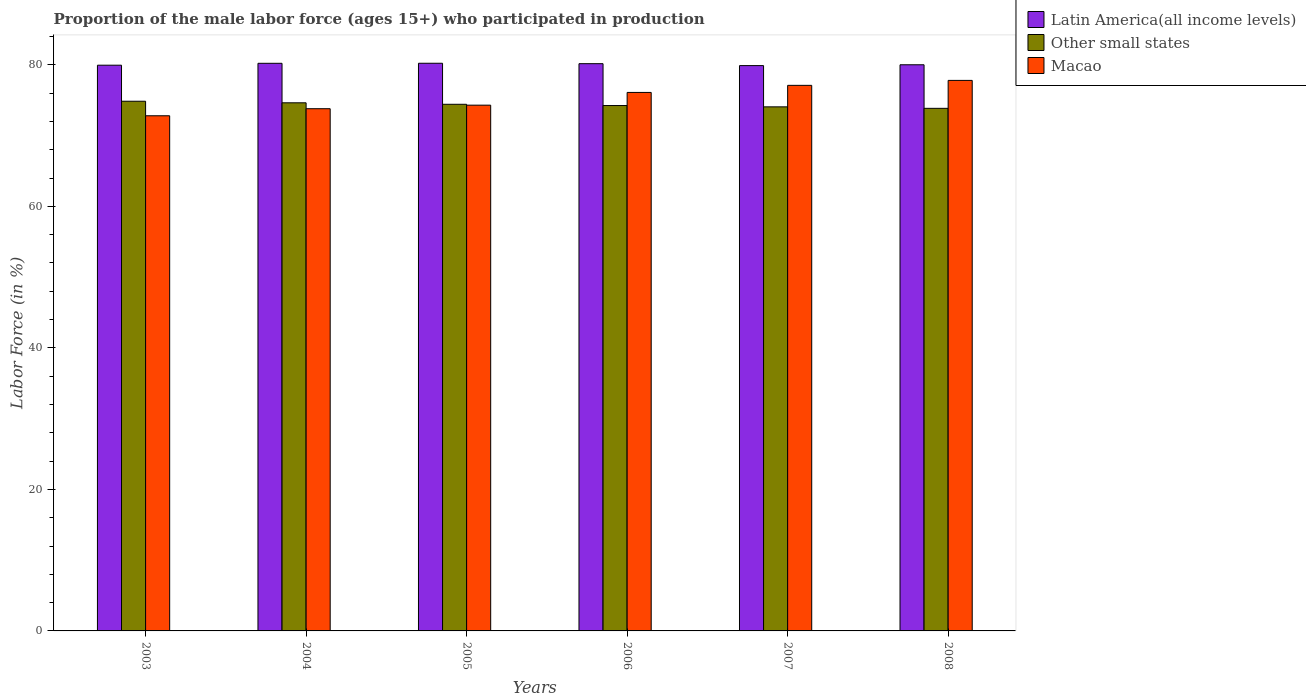How many groups of bars are there?
Provide a short and direct response. 6. Are the number of bars per tick equal to the number of legend labels?
Your answer should be very brief. Yes. Are the number of bars on each tick of the X-axis equal?
Your answer should be compact. Yes. How many bars are there on the 3rd tick from the left?
Ensure brevity in your answer.  3. How many bars are there on the 1st tick from the right?
Offer a terse response. 3. What is the label of the 4th group of bars from the left?
Your answer should be compact. 2006. In how many cases, is the number of bars for a given year not equal to the number of legend labels?
Keep it short and to the point. 0. What is the proportion of the male labor force who participated in production in Other small states in 2003?
Your answer should be very brief. 74.86. Across all years, what is the maximum proportion of the male labor force who participated in production in Macao?
Your answer should be compact. 77.8. Across all years, what is the minimum proportion of the male labor force who participated in production in Latin America(all income levels)?
Your answer should be compact. 79.89. In which year was the proportion of the male labor force who participated in production in Macao maximum?
Your answer should be compact. 2008. In which year was the proportion of the male labor force who participated in production in Other small states minimum?
Provide a succinct answer. 2008. What is the total proportion of the male labor force who participated in production in Other small states in the graph?
Ensure brevity in your answer.  446.07. What is the difference between the proportion of the male labor force who participated in production in Latin America(all income levels) in 2003 and that in 2007?
Keep it short and to the point. 0.06. What is the difference between the proportion of the male labor force who participated in production in Latin America(all income levels) in 2008 and the proportion of the male labor force who participated in production in Macao in 2005?
Your response must be concise. 5.71. What is the average proportion of the male labor force who participated in production in Other small states per year?
Your answer should be compact. 74.35. In the year 2008, what is the difference between the proportion of the male labor force who participated in production in Macao and proportion of the male labor force who participated in production in Latin America(all income levels)?
Offer a terse response. -2.21. What is the ratio of the proportion of the male labor force who participated in production in Other small states in 2003 to that in 2007?
Provide a succinct answer. 1.01. What is the difference between the highest and the second highest proportion of the male labor force who participated in production in Latin America(all income levels)?
Your answer should be compact. 0.01. What is the difference between the highest and the lowest proportion of the male labor force who participated in production in Other small states?
Your answer should be compact. 1. In how many years, is the proportion of the male labor force who participated in production in Macao greater than the average proportion of the male labor force who participated in production in Macao taken over all years?
Give a very brief answer. 3. What does the 3rd bar from the left in 2003 represents?
Keep it short and to the point. Macao. What does the 1st bar from the right in 2003 represents?
Your answer should be compact. Macao. Are all the bars in the graph horizontal?
Your answer should be very brief. No. How many years are there in the graph?
Keep it short and to the point. 6. Where does the legend appear in the graph?
Your answer should be very brief. Top right. How many legend labels are there?
Keep it short and to the point. 3. How are the legend labels stacked?
Your answer should be compact. Vertical. What is the title of the graph?
Give a very brief answer. Proportion of the male labor force (ages 15+) who participated in production. Does "Indonesia" appear as one of the legend labels in the graph?
Keep it short and to the point. No. What is the label or title of the X-axis?
Offer a terse response. Years. What is the Labor Force (in %) of Latin America(all income levels) in 2003?
Ensure brevity in your answer.  79.95. What is the Labor Force (in %) of Other small states in 2003?
Offer a very short reply. 74.86. What is the Labor Force (in %) in Macao in 2003?
Ensure brevity in your answer.  72.8. What is the Labor Force (in %) of Latin America(all income levels) in 2004?
Your response must be concise. 80.22. What is the Labor Force (in %) of Other small states in 2004?
Provide a succinct answer. 74.63. What is the Labor Force (in %) of Macao in 2004?
Give a very brief answer. 73.8. What is the Labor Force (in %) of Latin America(all income levels) in 2005?
Ensure brevity in your answer.  80.22. What is the Labor Force (in %) in Other small states in 2005?
Your answer should be compact. 74.42. What is the Labor Force (in %) of Macao in 2005?
Give a very brief answer. 74.3. What is the Labor Force (in %) in Latin America(all income levels) in 2006?
Make the answer very short. 80.16. What is the Labor Force (in %) in Other small states in 2006?
Your response must be concise. 74.25. What is the Labor Force (in %) in Macao in 2006?
Provide a short and direct response. 76.1. What is the Labor Force (in %) in Latin America(all income levels) in 2007?
Offer a terse response. 79.89. What is the Labor Force (in %) of Other small states in 2007?
Your answer should be very brief. 74.06. What is the Labor Force (in %) in Macao in 2007?
Give a very brief answer. 77.1. What is the Labor Force (in %) in Latin America(all income levels) in 2008?
Make the answer very short. 80.01. What is the Labor Force (in %) in Other small states in 2008?
Your answer should be very brief. 73.85. What is the Labor Force (in %) of Macao in 2008?
Give a very brief answer. 77.8. Across all years, what is the maximum Labor Force (in %) of Latin America(all income levels)?
Offer a very short reply. 80.22. Across all years, what is the maximum Labor Force (in %) in Other small states?
Your answer should be very brief. 74.86. Across all years, what is the maximum Labor Force (in %) in Macao?
Your response must be concise. 77.8. Across all years, what is the minimum Labor Force (in %) in Latin America(all income levels)?
Provide a short and direct response. 79.89. Across all years, what is the minimum Labor Force (in %) of Other small states?
Provide a succinct answer. 73.85. Across all years, what is the minimum Labor Force (in %) in Macao?
Provide a short and direct response. 72.8. What is the total Labor Force (in %) of Latin America(all income levels) in the graph?
Keep it short and to the point. 480.45. What is the total Labor Force (in %) in Other small states in the graph?
Make the answer very short. 446.07. What is the total Labor Force (in %) of Macao in the graph?
Your response must be concise. 451.9. What is the difference between the Labor Force (in %) of Latin America(all income levels) in 2003 and that in 2004?
Make the answer very short. -0.27. What is the difference between the Labor Force (in %) of Other small states in 2003 and that in 2004?
Offer a very short reply. 0.22. What is the difference between the Labor Force (in %) of Latin America(all income levels) in 2003 and that in 2005?
Ensure brevity in your answer.  -0.27. What is the difference between the Labor Force (in %) in Other small states in 2003 and that in 2005?
Your answer should be compact. 0.43. What is the difference between the Labor Force (in %) in Latin America(all income levels) in 2003 and that in 2006?
Provide a succinct answer. -0.21. What is the difference between the Labor Force (in %) in Other small states in 2003 and that in 2006?
Make the answer very short. 0.61. What is the difference between the Labor Force (in %) in Macao in 2003 and that in 2006?
Offer a terse response. -3.3. What is the difference between the Labor Force (in %) of Latin America(all income levels) in 2003 and that in 2007?
Your response must be concise. 0.06. What is the difference between the Labor Force (in %) in Other small states in 2003 and that in 2007?
Offer a very short reply. 0.79. What is the difference between the Labor Force (in %) in Latin America(all income levels) in 2003 and that in 2008?
Make the answer very short. -0.06. What is the difference between the Labor Force (in %) in Macao in 2003 and that in 2008?
Your response must be concise. -5. What is the difference between the Labor Force (in %) of Latin America(all income levels) in 2004 and that in 2005?
Your response must be concise. -0.01. What is the difference between the Labor Force (in %) of Other small states in 2004 and that in 2005?
Your answer should be compact. 0.21. What is the difference between the Labor Force (in %) in Macao in 2004 and that in 2005?
Keep it short and to the point. -0.5. What is the difference between the Labor Force (in %) in Latin America(all income levels) in 2004 and that in 2006?
Provide a short and direct response. 0.05. What is the difference between the Labor Force (in %) of Other small states in 2004 and that in 2006?
Your response must be concise. 0.39. What is the difference between the Labor Force (in %) of Latin America(all income levels) in 2004 and that in 2007?
Give a very brief answer. 0.32. What is the difference between the Labor Force (in %) of Other small states in 2004 and that in 2007?
Keep it short and to the point. 0.57. What is the difference between the Labor Force (in %) in Macao in 2004 and that in 2007?
Your answer should be very brief. -3.3. What is the difference between the Labor Force (in %) in Latin America(all income levels) in 2004 and that in 2008?
Keep it short and to the point. 0.21. What is the difference between the Labor Force (in %) of Other small states in 2004 and that in 2008?
Your answer should be compact. 0.78. What is the difference between the Labor Force (in %) of Macao in 2004 and that in 2008?
Offer a terse response. -4. What is the difference between the Labor Force (in %) of Latin America(all income levels) in 2005 and that in 2006?
Provide a succinct answer. 0.06. What is the difference between the Labor Force (in %) in Other small states in 2005 and that in 2006?
Your answer should be compact. 0.18. What is the difference between the Labor Force (in %) of Macao in 2005 and that in 2006?
Your answer should be very brief. -1.8. What is the difference between the Labor Force (in %) in Latin America(all income levels) in 2005 and that in 2007?
Make the answer very short. 0.33. What is the difference between the Labor Force (in %) in Other small states in 2005 and that in 2007?
Offer a terse response. 0.36. What is the difference between the Labor Force (in %) of Latin America(all income levels) in 2005 and that in 2008?
Offer a terse response. 0.21. What is the difference between the Labor Force (in %) of Other small states in 2005 and that in 2008?
Make the answer very short. 0.57. What is the difference between the Labor Force (in %) of Latin America(all income levels) in 2006 and that in 2007?
Your answer should be very brief. 0.27. What is the difference between the Labor Force (in %) in Other small states in 2006 and that in 2007?
Make the answer very short. 0.19. What is the difference between the Labor Force (in %) in Latin America(all income levels) in 2006 and that in 2008?
Your answer should be compact. 0.15. What is the difference between the Labor Force (in %) of Other small states in 2006 and that in 2008?
Your response must be concise. 0.4. What is the difference between the Labor Force (in %) of Macao in 2006 and that in 2008?
Give a very brief answer. -1.7. What is the difference between the Labor Force (in %) in Latin America(all income levels) in 2007 and that in 2008?
Ensure brevity in your answer.  -0.12. What is the difference between the Labor Force (in %) in Other small states in 2007 and that in 2008?
Your response must be concise. 0.21. What is the difference between the Labor Force (in %) in Macao in 2007 and that in 2008?
Give a very brief answer. -0.7. What is the difference between the Labor Force (in %) in Latin America(all income levels) in 2003 and the Labor Force (in %) in Other small states in 2004?
Your answer should be compact. 5.31. What is the difference between the Labor Force (in %) of Latin America(all income levels) in 2003 and the Labor Force (in %) of Macao in 2004?
Your response must be concise. 6.15. What is the difference between the Labor Force (in %) in Other small states in 2003 and the Labor Force (in %) in Macao in 2004?
Offer a terse response. 1.05. What is the difference between the Labor Force (in %) in Latin America(all income levels) in 2003 and the Labor Force (in %) in Other small states in 2005?
Your answer should be compact. 5.52. What is the difference between the Labor Force (in %) in Latin America(all income levels) in 2003 and the Labor Force (in %) in Macao in 2005?
Give a very brief answer. 5.65. What is the difference between the Labor Force (in %) in Other small states in 2003 and the Labor Force (in %) in Macao in 2005?
Provide a short and direct response. 0.56. What is the difference between the Labor Force (in %) in Latin America(all income levels) in 2003 and the Labor Force (in %) in Other small states in 2006?
Your answer should be compact. 5.7. What is the difference between the Labor Force (in %) of Latin America(all income levels) in 2003 and the Labor Force (in %) of Macao in 2006?
Offer a very short reply. 3.85. What is the difference between the Labor Force (in %) of Other small states in 2003 and the Labor Force (in %) of Macao in 2006?
Keep it short and to the point. -1.25. What is the difference between the Labor Force (in %) of Latin America(all income levels) in 2003 and the Labor Force (in %) of Other small states in 2007?
Make the answer very short. 5.89. What is the difference between the Labor Force (in %) of Latin America(all income levels) in 2003 and the Labor Force (in %) of Macao in 2007?
Make the answer very short. 2.85. What is the difference between the Labor Force (in %) of Other small states in 2003 and the Labor Force (in %) of Macao in 2007?
Give a very brief answer. -2.25. What is the difference between the Labor Force (in %) of Latin America(all income levels) in 2003 and the Labor Force (in %) of Other small states in 2008?
Provide a succinct answer. 6.1. What is the difference between the Labor Force (in %) in Latin America(all income levels) in 2003 and the Labor Force (in %) in Macao in 2008?
Your response must be concise. 2.15. What is the difference between the Labor Force (in %) of Other small states in 2003 and the Labor Force (in %) of Macao in 2008?
Offer a very short reply. -2.94. What is the difference between the Labor Force (in %) in Latin America(all income levels) in 2004 and the Labor Force (in %) in Other small states in 2005?
Your answer should be compact. 5.79. What is the difference between the Labor Force (in %) of Latin America(all income levels) in 2004 and the Labor Force (in %) of Macao in 2005?
Offer a terse response. 5.92. What is the difference between the Labor Force (in %) in Other small states in 2004 and the Labor Force (in %) in Macao in 2005?
Provide a short and direct response. 0.33. What is the difference between the Labor Force (in %) of Latin America(all income levels) in 2004 and the Labor Force (in %) of Other small states in 2006?
Your answer should be compact. 5.97. What is the difference between the Labor Force (in %) in Latin America(all income levels) in 2004 and the Labor Force (in %) in Macao in 2006?
Your response must be concise. 4.12. What is the difference between the Labor Force (in %) in Other small states in 2004 and the Labor Force (in %) in Macao in 2006?
Keep it short and to the point. -1.47. What is the difference between the Labor Force (in %) in Latin America(all income levels) in 2004 and the Labor Force (in %) in Other small states in 2007?
Provide a short and direct response. 6.15. What is the difference between the Labor Force (in %) of Latin America(all income levels) in 2004 and the Labor Force (in %) of Macao in 2007?
Ensure brevity in your answer.  3.12. What is the difference between the Labor Force (in %) of Other small states in 2004 and the Labor Force (in %) of Macao in 2007?
Give a very brief answer. -2.47. What is the difference between the Labor Force (in %) of Latin America(all income levels) in 2004 and the Labor Force (in %) of Other small states in 2008?
Offer a terse response. 6.36. What is the difference between the Labor Force (in %) in Latin America(all income levels) in 2004 and the Labor Force (in %) in Macao in 2008?
Your answer should be compact. 2.42. What is the difference between the Labor Force (in %) in Other small states in 2004 and the Labor Force (in %) in Macao in 2008?
Your response must be concise. -3.17. What is the difference between the Labor Force (in %) in Latin America(all income levels) in 2005 and the Labor Force (in %) in Other small states in 2006?
Offer a very short reply. 5.98. What is the difference between the Labor Force (in %) in Latin America(all income levels) in 2005 and the Labor Force (in %) in Macao in 2006?
Your answer should be very brief. 4.12. What is the difference between the Labor Force (in %) in Other small states in 2005 and the Labor Force (in %) in Macao in 2006?
Give a very brief answer. -1.68. What is the difference between the Labor Force (in %) of Latin America(all income levels) in 2005 and the Labor Force (in %) of Other small states in 2007?
Provide a succinct answer. 6.16. What is the difference between the Labor Force (in %) in Latin America(all income levels) in 2005 and the Labor Force (in %) in Macao in 2007?
Provide a succinct answer. 3.12. What is the difference between the Labor Force (in %) in Other small states in 2005 and the Labor Force (in %) in Macao in 2007?
Your answer should be compact. -2.68. What is the difference between the Labor Force (in %) of Latin America(all income levels) in 2005 and the Labor Force (in %) of Other small states in 2008?
Keep it short and to the point. 6.37. What is the difference between the Labor Force (in %) in Latin America(all income levels) in 2005 and the Labor Force (in %) in Macao in 2008?
Provide a short and direct response. 2.42. What is the difference between the Labor Force (in %) of Other small states in 2005 and the Labor Force (in %) of Macao in 2008?
Your response must be concise. -3.38. What is the difference between the Labor Force (in %) in Latin America(all income levels) in 2006 and the Labor Force (in %) in Other small states in 2007?
Ensure brevity in your answer.  6.1. What is the difference between the Labor Force (in %) of Latin America(all income levels) in 2006 and the Labor Force (in %) of Macao in 2007?
Provide a succinct answer. 3.06. What is the difference between the Labor Force (in %) in Other small states in 2006 and the Labor Force (in %) in Macao in 2007?
Offer a terse response. -2.85. What is the difference between the Labor Force (in %) of Latin America(all income levels) in 2006 and the Labor Force (in %) of Other small states in 2008?
Provide a succinct answer. 6.31. What is the difference between the Labor Force (in %) of Latin America(all income levels) in 2006 and the Labor Force (in %) of Macao in 2008?
Ensure brevity in your answer.  2.36. What is the difference between the Labor Force (in %) of Other small states in 2006 and the Labor Force (in %) of Macao in 2008?
Keep it short and to the point. -3.55. What is the difference between the Labor Force (in %) in Latin America(all income levels) in 2007 and the Labor Force (in %) in Other small states in 2008?
Your answer should be very brief. 6.04. What is the difference between the Labor Force (in %) of Latin America(all income levels) in 2007 and the Labor Force (in %) of Macao in 2008?
Ensure brevity in your answer.  2.09. What is the difference between the Labor Force (in %) of Other small states in 2007 and the Labor Force (in %) of Macao in 2008?
Your response must be concise. -3.74. What is the average Labor Force (in %) of Latin America(all income levels) per year?
Provide a short and direct response. 80.07. What is the average Labor Force (in %) in Other small states per year?
Provide a succinct answer. 74.35. What is the average Labor Force (in %) in Macao per year?
Ensure brevity in your answer.  75.32. In the year 2003, what is the difference between the Labor Force (in %) of Latin America(all income levels) and Labor Force (in %) of Other small states?
Your answer should be compact. 5.09. In the year 2003, what is the difference between the Labor Force (in %) of Latin America(all income levels) and Labor Force (in %) of Macao?
Your response must be concise. 7.15. In the year 2003, what is the difference between the Labor Force (in %) of Other small states and Labor Force (in %) of Macao?
Ensure brevity in your answer.  2.06. In the year 2004, what is the difference between the Labor Force (in %) in Latin America(all income levels) and Labor Force (in %) in Other small states?
Your response must be concise. 5.58. In the year 2004, what is the difference between the Labor Force (in %) in Latin America(all income levels) and Labor Force (in %) in Macao?
Provide a succinct answer. 6.42. In the year 2004, what is the difference between the Labor Force (in %) of Other small states and Labor Force (in %) of Macao?
Offer a terse response. 0.83. In the year 2005, what is the difference between the Labor Force (in %) of Latin America(all income levels) and Labor Force (in %) of Other small states?
Keep it short and to the point. 5.8. In the year 2005, what is the difference between the Labor Force (in %) of Latin America(all income levels) and Labor Force (in %) of Macao?
Keep it short and to the point. 5.92. In the year 2005, what is the difference between the Labor Force (in %) in Other small states and Labor Force (in %) in Macao?
Keep it short and to the point. 0.12. In the year 2006, what is the difference between the Labor Force (in %) in Latin America(all income levels) and Labor Force (in %) in Other small states?
Keep it short and to the point. 5.92. In the year 2006, what is the difference between the Labor Force (in %) in Latin America(all income levels) and Labor Force (in %) in Macao?
Offer a very short reply. 4.06. In the year 2006, what is the difference between the Labor Force (in %) in Other small states and Labor Force (in %) in Macao?
Make the answer very short. -1.85. In the year 2007, what is the difference between the Labor Force (in %) in Latin America(all income levels) and Labor Force (in %) in Other small states?
Offer a very short reply. 5.83. In the year 2007, what is the difference between the Labor Force (in %) of Latin America(all income levels) and Labor Force (in %) of Macao?
Give a very brief answer. 2.79. In the year 2007, what is the difference between the Labor Force (in %) of Other small states and Labor Force (in %) of Macao?
Provide a short and direct response. -3.04. In the year 2008, what is the difference between the Labor Force (in %) in Latin America(all income levels) and Labor Force (in %) in Other small states?
Give a very brief answer. 6.16. In the year 2008, what is the difference between the Labor Force (in %) in Latin America(all income levels) and Labor Force (in %) in Macao?
Your response must be concise. 2.21. In the year 2008, what is the difference between the Labor Force (in %) in Other small states and Labor Force (in %) in Macao?
Keep it short and to the point. -3.95. What is the ratio of the Labor Force (in %) of Macao in 2003 to that in 2004?
Your response must be concise. 0.99. What is the ratio of the Labor Force (in %) of Latin America(all income levels) in 2003 to that in 2005?
Provide a short and direct response. 1. What is the ratio of the Labor Force (in %) in Macao in 2003 to that in 2005?
Provide a short and direct response. 0.98. What is the ratio of the Labor Force (in %) of Latin America(all income levels) in 2003 to that in 2006?
Give a very brief answer. 1. What is the ratio of the Labor Force (in %) of Other small states in 2003 to that in 2006?
Keep it short and to the point. 1.01. What is the ratio of the Labor Force (in %) of Macao in 2003 to that in 2006?
Provide a short and direct response. 0.96. What is the ratio of the Labor Force (in %) of Other small states in 2003 to that in 2007?
Keep it short and to the point. 1.01. What is the ratio of the Labor Force (in %) of Macao in 2003 to that in 2007?
Keep it short and to the point. 0.94. What is the ratio of the Labor Force (in %) in Latin America(all income levels) in 2003 to that in 2008?
Offer a terse response. 1. What is the ratio of the Labor Force (in %) of Other small states in 2003 to that in 2008?
Make the answer very short. 1.01. What is the ratio of the Labor Force (in %) of Macao in 2003 to that in 2008?
Give a very brief answer. 0.94. What is the ratio of the Labor Force (in %) of Macao in 2004 to that in 2006?
Your answer should be very brief. 0.97. What is the ratio of the Labor Force (in %) of Latin America(all income levels) in 2004 to that in 2007?
Your answer should be very brief. 1. What is the ratio of the Labor Force (in %) in Other small states in 2004 to that in 2007?
Provide a short and direct response. 1.01. What is the ratio of the Labor Force (in %) in Macao in 2004 to that in 2007?
Provide a short and direct response. 0.96. What is the ratio of the Labor Force (in %) in Latin America(all income levels) in 2004 to that in 2008?
Give a very brief answer. 1. What is the ratio of the Labor Force (in %) in Other small states in 2004 to that in 2008?
Give a very brief answer. 1.01. What is the ratio of the Labor Force (in %) in Macao in 2004 to that in 2008?
Provide a succinct answer. 0.95. What is the ratio of the Labor Force (in %) of Latin America(all income levels) in 2005 to that in 2006?
Provide a short and direct response. 1. What is the ratio of the Labor Force (in %) of Other small states in 2005 to that in 2006?
Offer a very short reply. 1. What is the ratio of the Labor Force (in %) of Macao in 2005 to that in 2006?
Offer a very short reply. 0.98. What is the ratio of the Labor Force (in %) of Latin America(all income levels) in 2005 to that in 2007?
Make the answer very short. 1. What is the ratio of the Labor Force (in %) of Macao in 2005 to that in 2007?
Ensure brevity in your answer.  0.96. What is the ratio of the Labor Force (in %) of Latin America(all income levels) in 2005 to that in 2008?
Offer a very short reply. 1. What is the ratio of the Labor Force (in %) of Other small states in 2005 to that in 2008?
Your response must be concise. 1.01. What is the ratio of the Labor Force (in %) of Macao in 2005 to that in 2008?
Your answer should be compact. 0.95. What is the ratio of the Labor Force (in %) in Latin America(all income levels) in 2006 to that in 2007?
Your answer should be compact. 1. What is the ratio of the Labor Force (in %) of Other small states in 2006 to that in 2007?
Provide a succinct answer. 1. What is the ratio of the Labor Force (in %) in Macao in 2006 to that in 2007?
Your answer should be compact. 0.99. What is the ratio of the Labor Force (in %) of Latin America(all income levels) in 2006 to that in 2008?
Your answer should be very brief. 1. What is the ratio of the Labor Force (in %) in Other small states in 2006 to that in 2008?
Provide a succinct answer. 1.01. What is the ratio of the Labor Force (in %) in Macao in 2006 to that in 2008?
Your answer should be very brief. 0.98. What is the ratio of the Labor Force (in %) of Latin America(all income levels) in 2007 to that in 2008?
Your answer should be very brief. 1. What is the difference between the highest and the second highest Labor Force (in %) of Latin America(all income levels)?
Offer a very short reply. 0.01. What is the difference between the highest and the second highest Labor Force (in %) of Other small states?
Offer a terse response. 0.22. What is the difference between the highest and the lowest Labor Force (in %) in Latin America(all income levels)?
Your response must be concise. 0.33. 